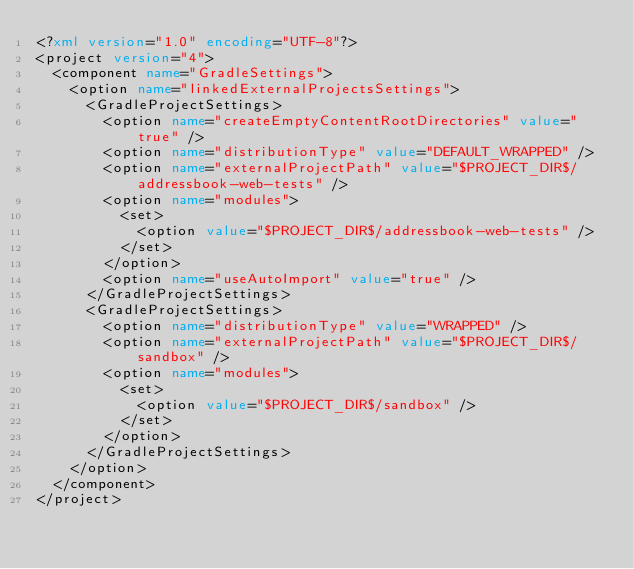Convert code to text. <code><loc_0><loc_0><loc_500><loc_500><_XML_><?xml version="1.0" encoding="UTF-8"?>
<project version="4">
  <component name="GradleSettings">
    <option name="linkedExternalProjectsSettings">
      <GradleProjectSettings>
        <option name="createEmptyContentRootDirectories" value="true" />
        <option name="distributionType" value="DEFAULT_WRAPPED" />
        <option name="externalProjectPath" value="$PROJECT_DIR$/addressbook-web-tests" />
        <option name="modules">
          <set>
            <option value="$PROJECT_DIR$/addressbook-web-tests" />
          </set>
        </option>
        <option name="useAutoImport" value="true" />
      </GradleProjectSettings>
      <GradleProjectSettings>
        <option name="distributionType" value="WRAPPED" />
        <option name="externalProjectPath" value="$PROJECT_DIR$/sandbox" />
        <option name="modules">
          <set>
            <option value="$PROJECT_DIR$/sandbox" />
          </set>
        </option>
      </GradleProjectSettings>
    </option>
  </component>
</project></code> 